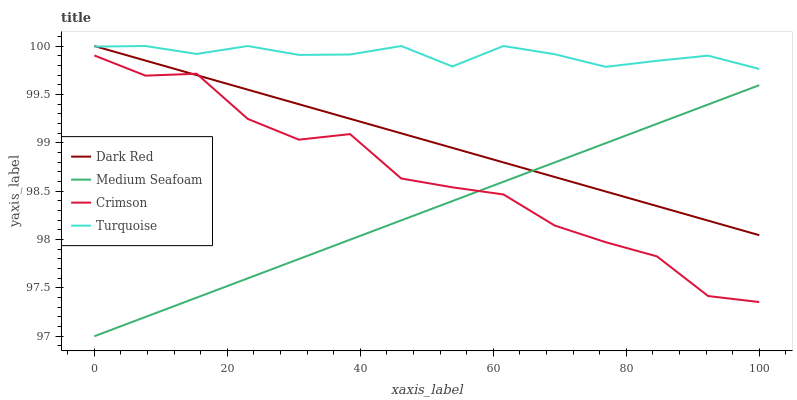Does Medium Seafoam have the minimum area under the curve?
Answer yes or no. Yes. Does Turquoise have the maximum area under the curve?
Answer yes or no. Yes. Does Dark Red have the minimum area under the curve?
Answer yes or no. No. Does Dark Red have the maximum area under the curve?
Answer yes or no. No. Is Medium Seafoam the smoothest?
Answer yes or no. Yes. Is Crimson the roughest?
Answer yes or no. Yes. Is Dark Red the smoothest?
Answer yes or no. No. Is Dark Red the roughest?
Answer yes or no. No. Does Medium Seafoam have the lowest value?
Answer yes or no. Yes. Does Dark Red have the lowest value?
Answer yes or no. No. Does Turquoise have the highest value?
Answer yes or no. Yes. Does Medium Seafoam have the highest value?
Answer yes or no. No. Is Crimson less than Turquoise?
Answer yes or no. Yes. Is Turquoise greater than Crimson?
Answer yes or no. Yes. Does Crimson intersect Medium Seafoam?
Answer yes or no. Yes. Is Crimson less than Medium Seafoam?
Answer yes or no. No. Is Crimson greater than Medium Seafoam?
Answer yes or no. No. Does Crimson intersect Turquoise?
Answer yes or no. No. 